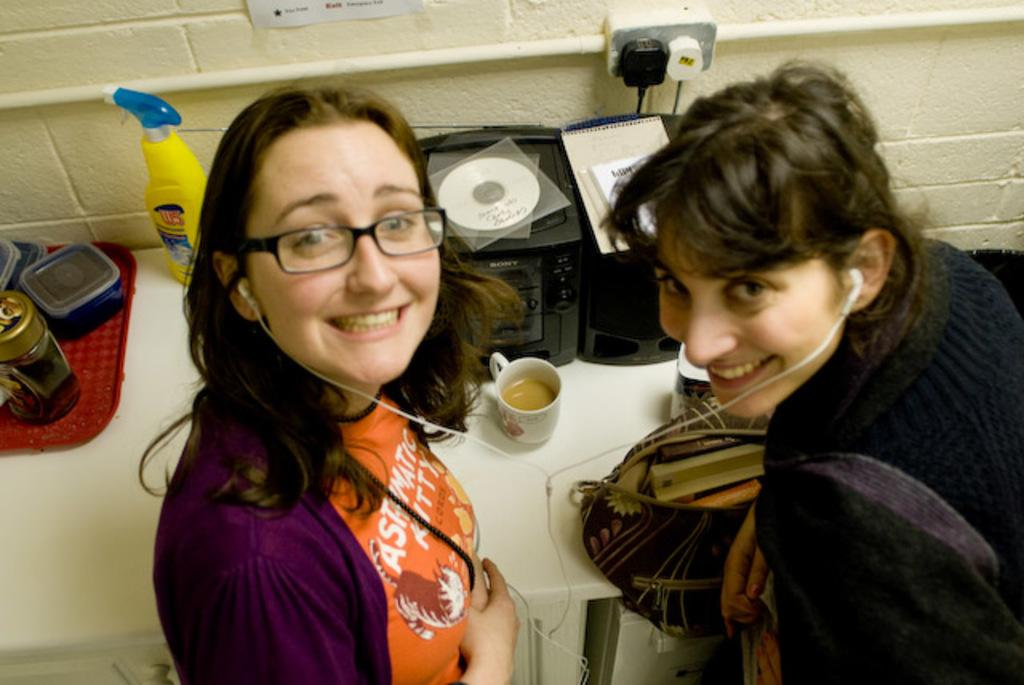How many women are in the image? There are two women in the image. What are the women wearing? Both women are wearing jackets. What can be seen on the table in the image? There is a music player on the table. What is the color of the table? The table is white in color. What type of rice is being served on the lace tablecloth in the image? There is no rice or lace tablecloth present in the image. 